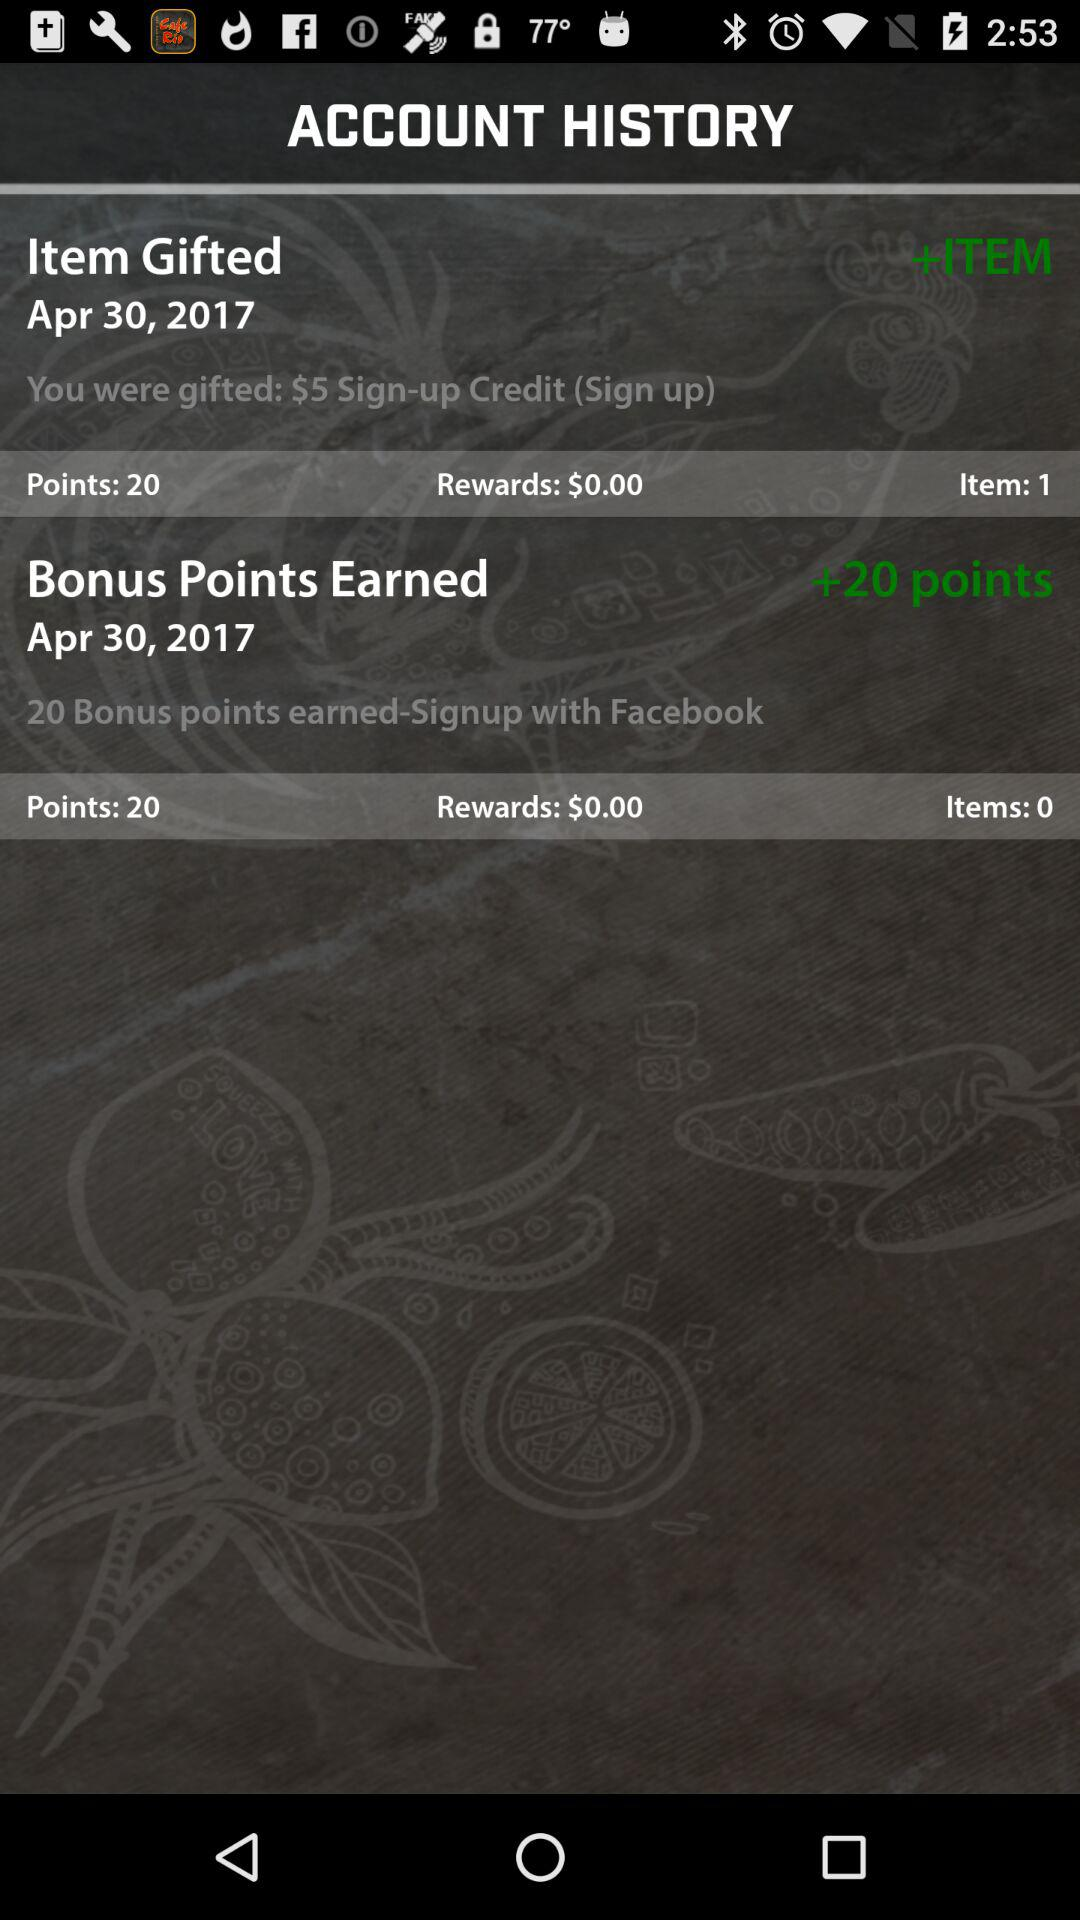On what date are bonus points earned? The date is April 30, 2017. 